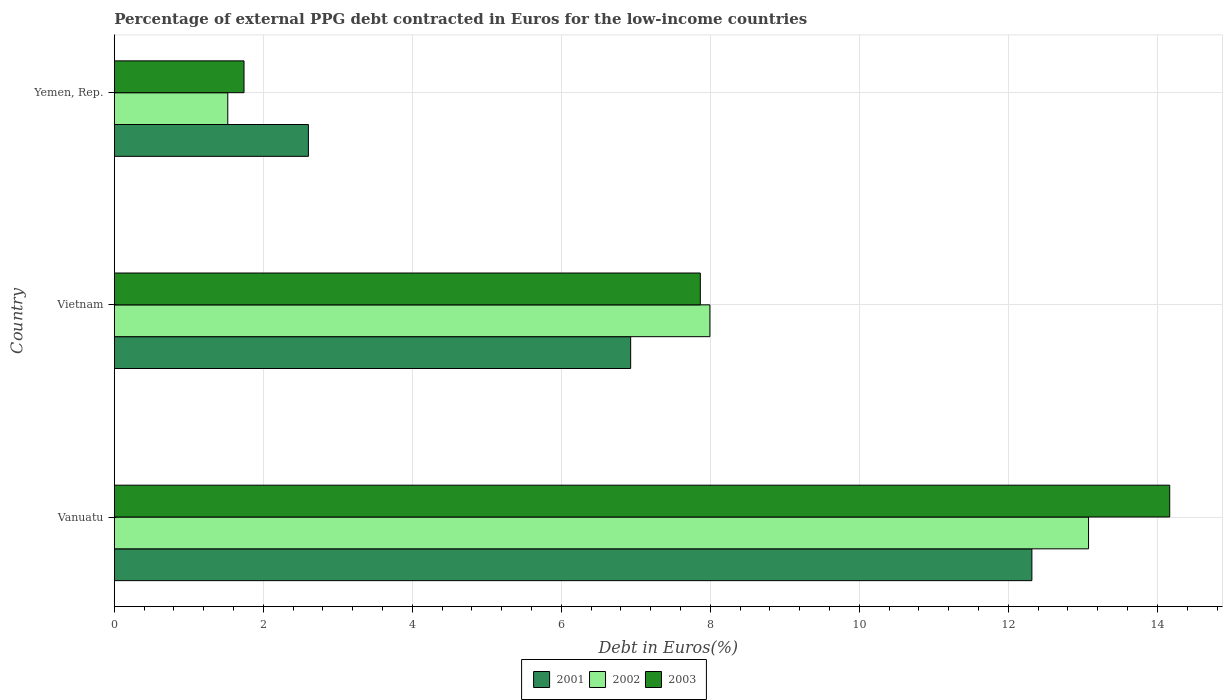Are the number of bars per tick equal to the number of legend labels?
Your answer should be compact. Yes. Are the number of bars on each tick of the Y-axis equal?
Your answer should be compact. Yes. What is the label of the 2nd group of bars from the top?
Provide a succinct answer. Vietnam. In how many cases, is the number of bars for a given country not equal to the number of legend labels?
Give a very brief answer. 0. What is the percentage of external PPG debt contracted in Euros in 2002 in Yemen, Rep.?
Keep it short and to the point. 1.52. Across all countries, what is the maximum percentage of external PPG debt contracted in Euros in 2003?
Provide a short and direct response. 14.17. Across all countries, what is the minimum percentage of external PPG debt contracted in Euros in 2002?
Your answer should be very brief. 1.52. In which country was the percentage of external PPG debt contracted in Euros in 2001 maximum?
Your response must be concise. Vanuatu. In which country was the percentage of external PPG debt contracted in Euros in 2001 minimum?
Your answer should be very brief. Yemen, Rep. What is the total percentage of external PPG debt contracted in Euros in 2003 in the graph?
Offer a very short reply. 23.77. What is the difference between the percentage of external PPG debt contracted in Euros in 2001 in Vanuatu and that in Vietnam?
Make the answer very short. 5.39. What is the difference between the percentage of external PPG debt contracted in Euros in 2003 in Yemen, Rep. and the percentage of external PPG debt contracted in Euros in 2002 in Vanuatu?
Give a very brief answer. -11.33. What is the average percentage of external PPG debt contracted in Euros in 2003 per country?
Offer a terse response. 7.92. What is the difference between the percentage of external PPG debt contracted in Euros in 2001 and percentage of external PPG debt contracted in Euros in 2003 in Vanuatu?
Give a very brief answer. -1.85. What is the ratio of the percentage of external PPG debt contracted in Euros in 2002 in Vanuatu to that in Yemen, Rep.?
Offer a terse response. 8.59. What is the difference between the highest and the second highest percentage of external PPG debt contracted in Euros in 2002?
Your answer should be very brief. 5.08. What is the difference between the highest and the lowest percentage of external PPG debt contracted in Euros in 2001?
Ensure brevity in your answer.  9.71. In how many countries, is the percentage of external PPG debt contracted in Euros in 2003 greater than the average percentage of external PPG debt contracted in Euros in 2003 taken over all countries?
Ensure brevity in your answer.  1. Is the sum of the percentage of external PPG debt contracted in Euros in 2001 in Vanuatu and Vietnam greater than the maximum percentage of external PPG debt contracted in Euros in 2003 across all countries?
Offer a very short reply. Yes. What does the 2nd bar from the top in Vietnam represents?
Ensure brevity in your answer.  2002. What does the 2nd bar from the bottom in Vietnam represents?
Your answer should be very brief. 2002. Is it the case that in every country, the sum of the percentage of external PPG debt contracted in Euros in 2002 and percentage of external PPG debt contracted in Euros in 2001 is greater than the percentage of external PPG debt contracted in Euros in 2003?
Provide a succinct answer. Yes. What is the difference between two consecutive major ticks on the X-axis?
Give a very brief answer. 2. Are the values on the major ticks of X-axis written in scientific E-notation?
Give a very brief answer. No. Does the graph contain any zero values?
Offer a terse response. No. Does the graph contain grids?
Your answer should be very brief. Yes. Where does the legend appear in the graph?
Provide a succinct answer. Bottom center. How many legend labels are there?
Give a very brief answer. 3. How are the legend labels stacked?
Offer a terse response. Horizontal. What is the title of the graph?
Your response must be concise. Percentage of external PPG debt contracted in Euros for the low-income countries. Does "1997" appear as one of the legend labels in the graph?
Keep it short and to the point. No. What is the label or title of the X-axis?
Your answer should be compact. Debt in Euros(%). What is the label or title of the Y-axis?
Give a very brief answer. Country. What is the Debt in Euros(%) in 2001 in Vanuatu?
Ensure brevity in your answer.  12.32. What is the Debt in Euros(%) of 2002 in Vanuatu?
Provide a succinct answer. 13.08. What is the Debt in Euros(%) in 2003 in Vanuatu?
Your answer should be compact. 14.17. What is the Debt in Euros(%) in 2001 in Vietnam?
Ensure brevity in your answer.  6.93. What is the Debt in Euros(%) in 2002 in Vietnam?
Offer a terse response. 7.99. What is the Debt in Euros(%) in 2003 in Vietnam?
Your answer should be very brief. 7.87. What is the Debt in Euros(%) of 2001 in Yemen, Rep.?
Give a very brief answer. 2.6. What is the Debt in Euros(%) of 2002 in Yemen, Rep.?
Offer a very short reply. 1.52. What is the Debt in Euros(%) in 2003 in Yemen, Rep.?
Offer a very short reply. 1.74. Across all countries, what is the maximum Debt in Euros(%) in 2001?
Ensure brevity in your answer.  12.32. Across all countries, what is the maximum Debt in Euros(%) in 2002?
Give a very brief answer. 13.08. Across all countries, what is the maximum Debt in Euros(%) of 2003?
Your answer should be compact. 14.17. Across all countries, what is the minimum Debt in Euros(%) of 2001?
Make the answer very short. 2.6. Across all countries, what is the minimum Debt in Euros(%) of 2002?
Provide a succinct answer. 1.52. Across all countries, what is the minimum Debt in Euros(%) of 2003?
Provide a short and direct response. 1.74. What is the total Debt in Euros(%) of 2001 in the graph?
Provide a succinct answer. 21.85. What is the total Debt in Euros(%) of 2002 in the graph?
Make the answer very short. 22.59. What is the total Debt in Euros(%) of 2003 in the graph?
Ensure brevity in your answer.  23.77. What is the difference between the Debt in Euros(%) in 2001 in Vanuatu and that in Vietnam?
Offer a very short reply. 5.39. What is the difference between the Debt in Euros(%) in 2002 in Vanuatu and that in Vietnam?
Your answer should be very brief. 5.08. What is the difference between the Debt in Euros(%) in 2003 in Vanuatu and that in Vietnam?
Provide a short and direct response. 6.3. What is the difference between the Debt in Euros(%) of 2001 in Vanuatu and that in Yemen, Rep.?
Provide a short and direct response. 9.71. What is the difference between the Debt in Euros(%) in 2002 in Vanuatu and that in Yemen, Rep.?
Your answer should be compact. 11.55. What is the difference between the Debt in Euros(%) of 2003 in Vanuatu and that in Yemen, Rep.?
Offer a very short reply. 12.42. What is the difference between the Debt in Euros(%) in 2001 in Vietnam and that in Yemen, Rep.?
Your answer should be very brief. 4.33. What is the difference between the Debt in Euros(%) of 2002 in Vietnam and that in Yemen, Rep.?
Make the answer very short. 6.47. What is the difference between the Debt in Euros(%) of 2003 in Vietnam and that in Yemen, Rep.?
Offer a very short reply. 6.12. What is the difference between the Debt in Euros(%) of 2001 in Vanuatu and the Debt in Euros(%) of 2002 in Vietnam?
Provide a succinct answer. 4.32. What is the difference between the Debt in Euros(%) of 2001 in Vanuatu and the Debt in Euros(%) of 2003 in Vietnam?
Keep it short and to the point. 4.45. What is the difference between the Debt in Euros(%) of 2002 in Vanuatu and the Debt in Euros(%) of 2003 in Vietnam?
Provide a succinct answer. 5.21. What is the difference between the Debt in Euros(%) in 2001 in Vanuatu and the Debt in Euros(%) in 2002 in Yemen, Rep.?
Make the answer very short. 10.79. What is the difference between the Debt in Euros(%) of 2001 in Vanuatu and the Debt in Euros(%) of 2003 in Yemen, Rep.?
Offer a terse response. 10.57. What is the difference between the Debt in Euros(%) in 2002 in Vanuatu and the Debt in Euros(%) in 2003 in Yemen, Rep.?
Keep it short and to the point. 11.33. What is the difference between the Debt in Euros(%) of 2001 in Vietnam and the Debt in Euros(%) of 2002 in Yemen, Rep.?
Make the answer very short. 5.41. What is the difference between the Debt in Euros(%) in 2001 in Vietnam and the Debt in Euros(%) in 2003 in Yemen, Rep.?
Your response must be concise. 5.19. What is the difference between the Debt in Euros(%) in 2002 in Vietnam and the Debt in Euros(%) in 2003 in Yemen, Rep.?
Your answer should be compact. 6.25. What is the average Debt in Euros(%) of 2001 per country?
Ensure brevity in your answer.  7.28. What is the average Debt in Euros(%) in 2002 per country?
Make the answer very short. 7.53. What is the average Debt in Euros(%) of 2003 per country?
Offer a very short reply. 7.92. What is the difference between the Debt in Euros(%) of 2001 and Debt in Euros(%) of 2002 in Vanuatu?
Offer a terse response. -0.76. What is the difference between the Debt in Euros(%) of 2001 and Debt in Euros(%) of 2003 in Vanuatu?
Your answer should be compact. -1.85. What is the difference between the Debt in Euros(%) in 2002 and Debt in Euros(%) in 2003 in Vanuatu?
Provide a short and direct response. -1.09. What is the difference between the Debt in Euros(%) in 2001 and Debt in Euros(%) in 2002 in Vietnam?
Keep it short and to the point. -1.06. What is the difference between the Debt in Euros(%) of 2001 and Debt in Euros(%) of 2003 in Vietnam?
Your answer should be compact. -0.94. What is the difference between the Debt in Euros(%) of 2002 and Debt in Euros(%) of 2003 in Vietnam?
Your answer should be very brief. 0.13. What is the difference between the Debt in Euros(%) in 2001 and Debt in Euros(%) in 2002 in Yemen, Rep.?
Your response must be concise. 1.08. What is the difference between the Debt in Euros(%) of 2001 and Debt in Euros(%) of 2003 in Yemen, Rep.?
Provide a succinct answer. 0.86. What is the difference between the Debt in Euros(%) of 2002 and Debt in Euros(%) of 2003 in Yemen, Rep.?
Offer a terse response. -0.22. What is the ratio of the Debt in Euros(%) in 2001 in Vanuatu to that in Vietnam?
Offer a very short reply. 1.78. What is the ratio of the Debt in Euros(%) of 2002 in Vanuatu to that in Vietnam?
Your answer should be compact. 1.64. What is the ratio of the Debt in Euros(%) of 2003 in Vanuatu to that in Vietnam?
Keep it short and to the point. 1.8. What is the ratio of the Debt in Euros(%) in 2001 in Vanuatu to that in Yemen, Rep.?
Keep it short and to the point. 4.73. What is the ratio of the Debt in Euros(%) of 2002 in Vanuatu to that in Yemen, Rep.?
Your answer should be compact. 8.59. What is the ratio of the Debt in Euros(%) in 2003 in Vanuatu to that in Yemen, Rep.?
Offer a very short reply. 8.14. What is the ratio of the Debt in Euros(%) in 2001 in Vietnam to that in Yemen, Rep.?
Offer a very short reply. 2.66. What is the ratio of the Debt in Euros(%) in 2002 in Vietnam to that in Yemen, Rep.?
Give a very brief answer. 5.25. What is the ratio of the Debt in Euros(%) of 2003 in Vietnam to that in Yemen, Rep.?
Provide a succinct answer. 4.52. What is the difference between the highest and the second highest Debt in Euros(%) in 2001?
Keep it short and to the point. 5.39. What is the difference between the highest and the second highest Debt in Euros(%) of 2002?
Provide a short and direct response. 5.08. What is the difference between the highest and the second highest Debt in Euros(%) in 2003?
Provide a short and direct response. 6.3. What is the difference between the highest and the lowest Debt in Euros(%) in 2001?
Make the answer very short. 9.71. What is the difference between the highest and the lowest Debt in Euros(%) in 2002?
Offer a very short reply. 11.55. What is the difference between the highest and the lowest Debt in Euros(%) in 2003?
Offer a very short reply. 12.42. 